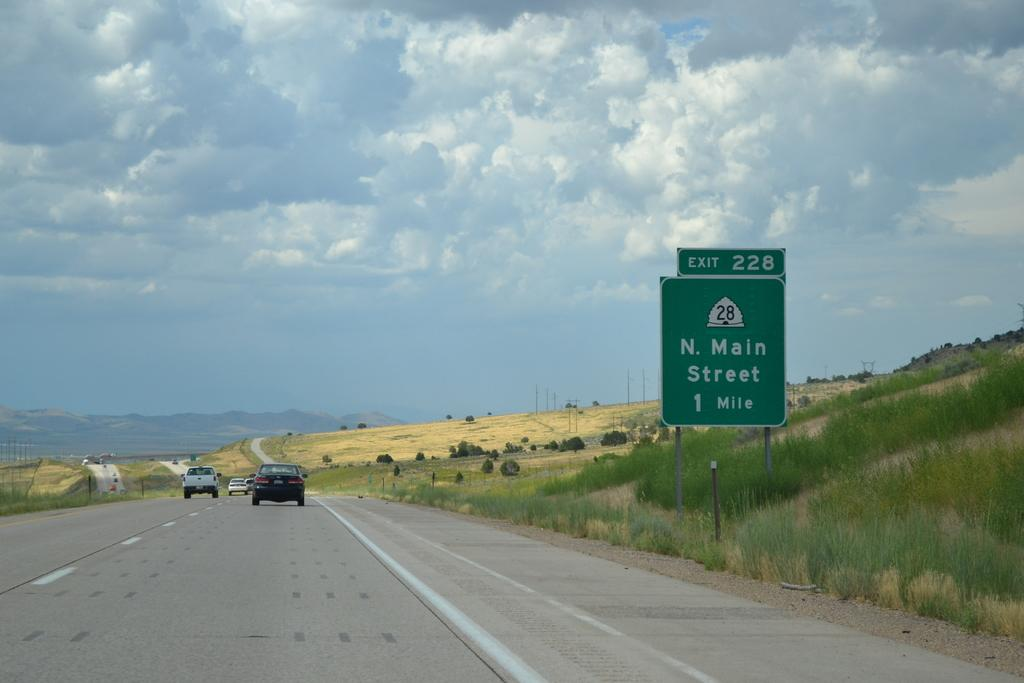<image>
Present a compact description of the photo's key features. Exit 228 in 1 mile for N. Main Street. 